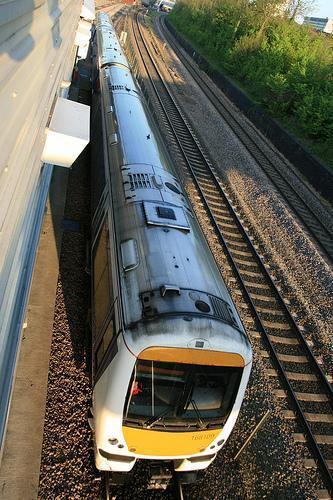How many trains are visible?
Give a very brief answer. 1. How many pairs of tracks are shown?
Give a very brief answer. 3. 